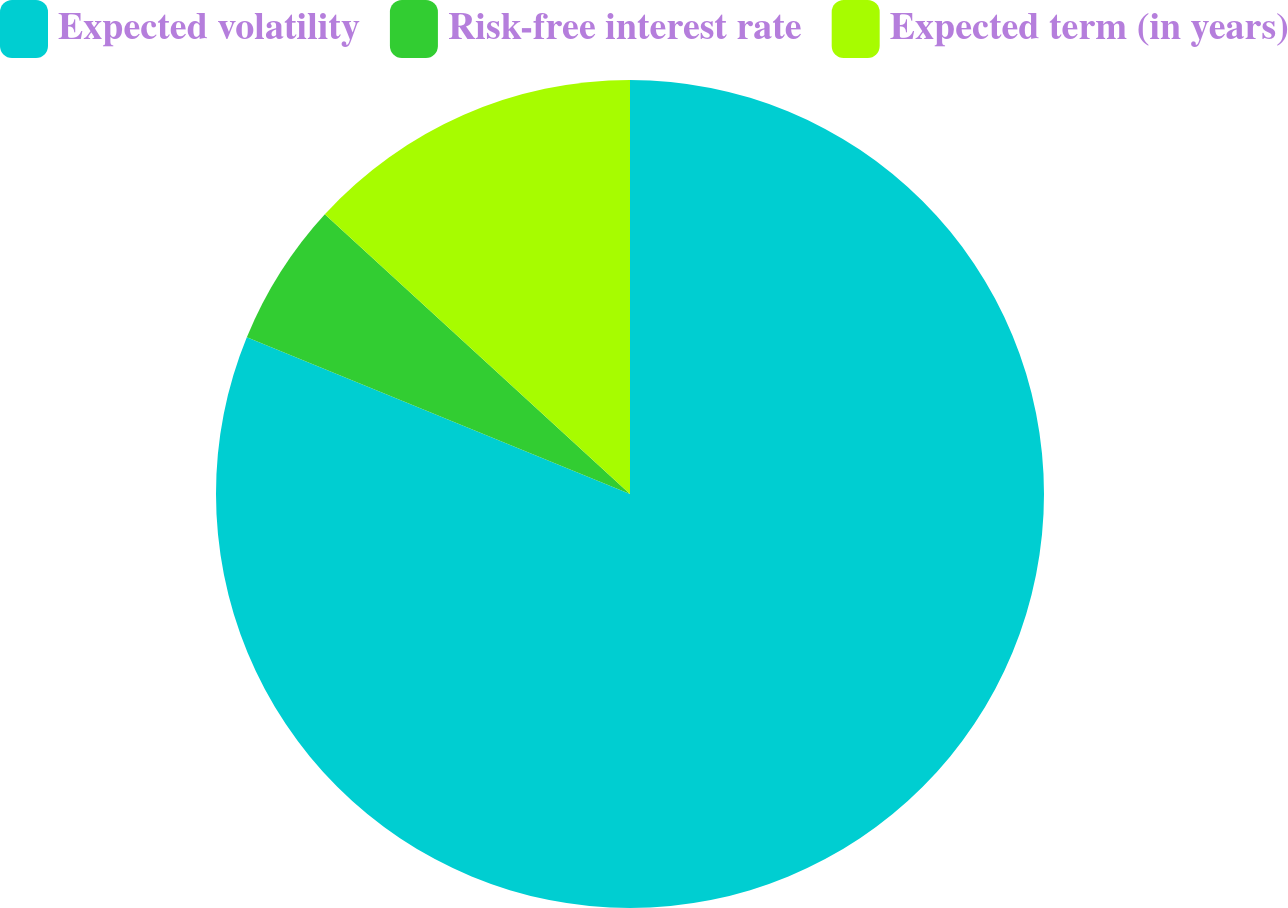Convert chart. <chart><loc_0><loc_0><loc_500><loc_500><pie_chart><fcel>Expected volatility<fcel>Risk-free interest rate<fcel>Expected term (in years)<nl><fcel>81.18%<fcel>5.63%<fcel>13.19%<nl></chart> 